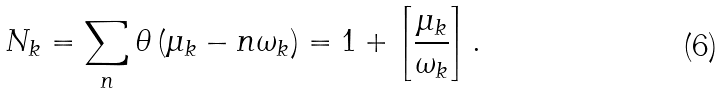<formula> <loc_0><loc_0><loc_500><loc_500>N _ { k } = \sum _ { n } \theta \left ( \mu _ { k } - n \omega _ { k } \right ) = 1 + \left [ \frac { \mu _ { k } } { \omega _ { k } } \right ] .</formula> 